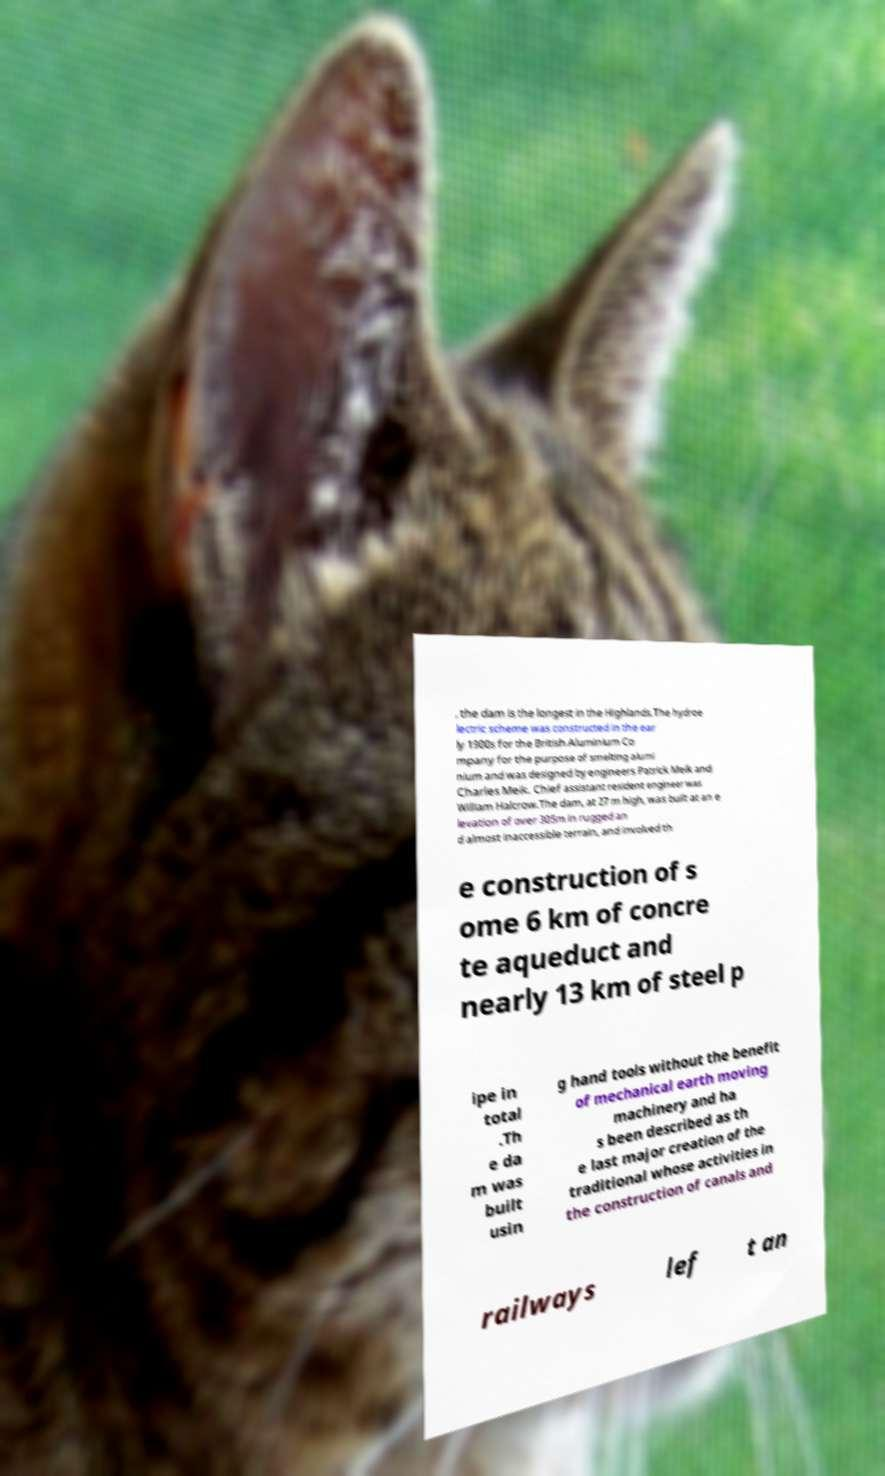For documentation purposes, I need the text within this image transcribed. Could you provide that? , the dam is the longest in the Highlands.The hydroe lectric scheme was constructed in the ear ly 1900s for the British Aluminium Co mpany for the purpose of smelting alumi nium and was designed by engineers Patrick Meik and Charles Meik. Chief assistant resident engineer was William Halcrow.The dam, at 27 m high, was built at an e levation of over 305m in rugged an d almost inaccessible terrain, and involved th e construction of s ome 6 km of concre te aqueduct and nearly 13 km of steel p ipe in total .Th e da m was built usin g hand tools without the benefit of mechanical earth moving machinery and ha s been described as th e last major creation of the traditional whose activities in the construction of canals and railways lef t an 